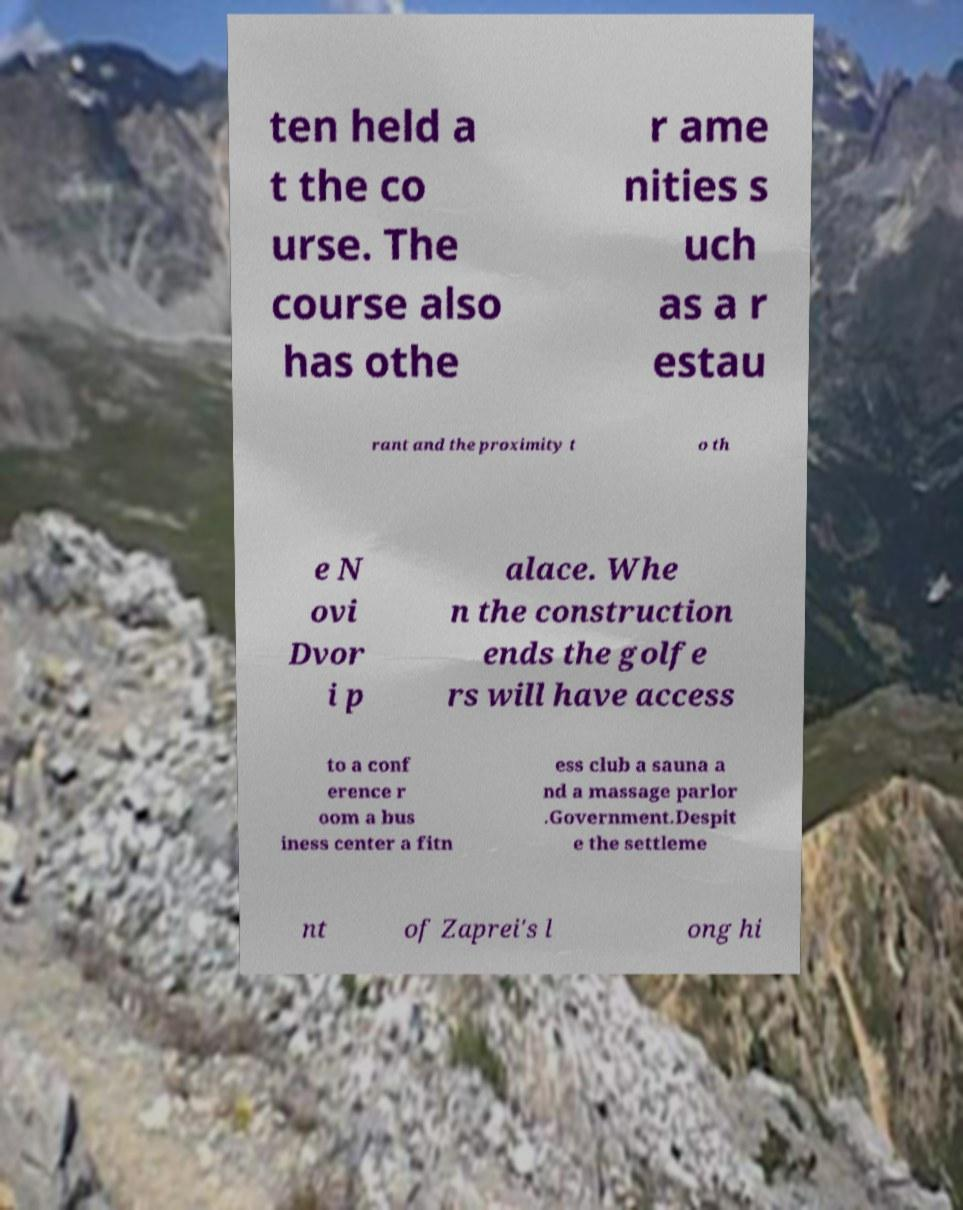Please read and relay the text visible in this image. What does it say? ten held a t the co urse. The course also has othe r ame nities s uch as a r estau rant and the proximity t o th e N ovi Dvor i p alace. Whe n the construction ends the golfe rs will have access to a conf erence r oom a bus iness center a fitn ess club a sauna a nd a massage parlor .Government.Despit e the settleme nt of Zaprei's l ong hi 